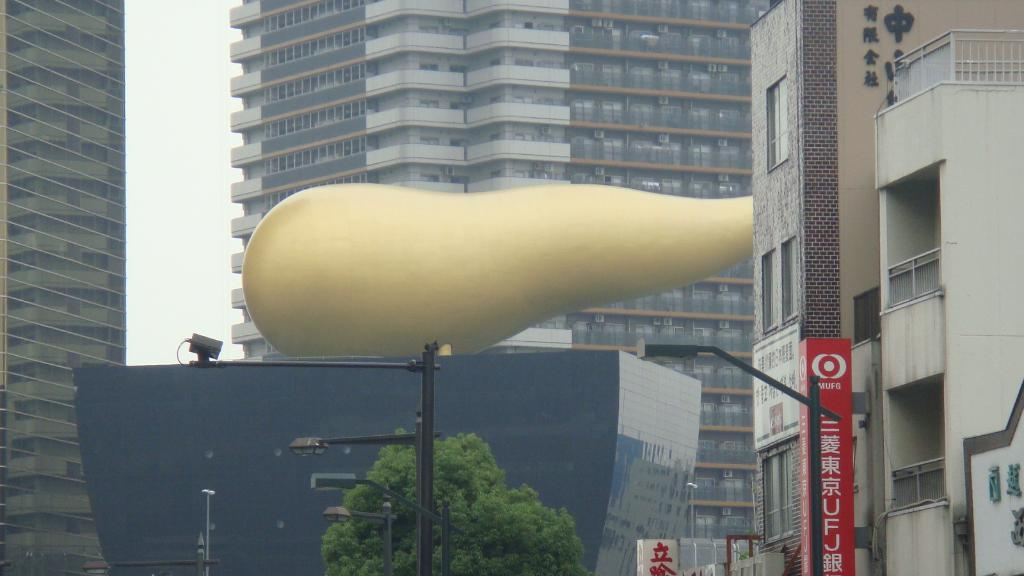What type of structures can be seen in the image? There are buildings in the image. What natural element is present in the image? There is a tree in the image. What type of lighting is visible in the image? There are pole lights in the image. What type of signage is present in the image? There are boards with text in the image. What might be a decorative or artistic object in the image? The image appears to contain a showpiece. What is the weather condition in the image? The sky is cloudy in the image. What type of corn is being harvested in the image? There is no corn present in the image; it features buildings, a tree, pole lights, boards with text, a showpiece, and a cloudy sky. What invention is being demonstrated in the image? There is no invention being demonstrated in the image; it features a scene with buildings, a tree, pole lights, boards with text, a showpiece, and a cloudy sky. 